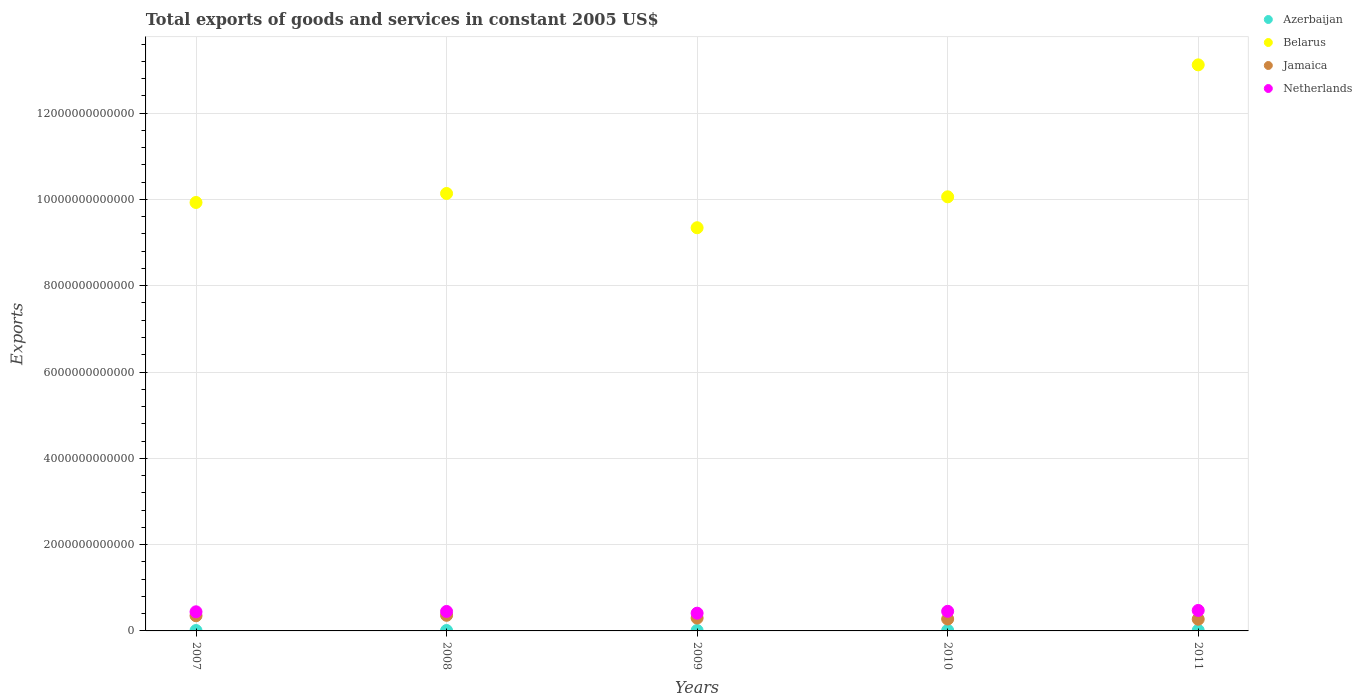How many different coloured dotlines are there?
Provide a short and direct response. 4. What is the total exports of goods and services in Belarus in 2011?
Offer a very short reply. 1.31e+13. Across all years, what is the maximum total exports of goods and services in Belarus?
Provide a succinct answer. 1.31e+13. Across all years, what is the minimum total exports of goods and services in Jamaica?
Give a very brief answer. 2.71e+11. In which year was the total exports of goods and services in Belarus maximum?
Offer a terse response. 2011. In which year was the total exports of goods and services in Netherlands minimum?
Provide a short and direct response. 2009. What is the total total exports of goods and services in Jamaica in the graph?
Your answer should be very brief. 1.56e+12. What is the difference between the total exports of goods and services in Netherlands in 2007 and that in 2009?
Your answer should be compact. 3.20e+1. What is the difference between the total exports of goods and services in Belarus in 2011 and the total exports of goods and services in Netherlands in 2009?
Your response must be concise. 1.27e+13. What is the average total exports of goods and services in Azerbaijan per year?
Your answer should be very brief. 1.10e+1. In the year 2008, what is the difference between the total exports of goods and services in Azerbaijan and total exports of goods and services in Belarus?
Ensure brevity in your answer.  -1.01e+13. In how many years, is the total exports of goods and services in Netherlands greater than 1200000000000 US$?
Provide a succinct answer. 0. What is the ratio of the total exports of goods and services in Belarus in 2009 to that in 2011?
Provide a short and direct response. 0.71. Is the total exports of goods and services in Jamaica in 2009 less than that in 2010?
Provide a succinct answer. No. What is the difference between the highest and the second highest total exports of goods and services in Belarus?
Ensure brevity in your answer.  2.98e+12. What is the difference between the highest and the lowest total exports of goods and services in Azerbaijan?
Provide a short and direct response. 4.42e+09. In how many years, is the total exports of goods and services in Belarus greater than the average total exports of goods and services in Belarus taken over all years?
Provide a short and direct response. 1. Does the total exports of goods and services in Azerbaijan monotonically increase over the years?
Give a very brief answer. Yes. Is the total exports of goods and services in Belarus strictly greater than the total exports of goods and services in Jamaica over the years?
Give a very brief answer. Yes. Is the total exports of goods and services in Belarus strictly less than the total exports of goods and services in Jamaica over the years?
Provide a succinct answer. No. How many years are there in the graph?
Your response must be concise. 5. What is the difference between two consecutive major ticks on the Y-axis?
Your response must be concise. 2.00e+12. How are the legend labels stacked?
Provide a succinct answer. Vertical. What is the title of the graph?
Your answer should be very brief. Total exports of goods and services in constant 2005 US$. Does "Ukraine" appear as one of the legend labels in the graph?
Offer a terse response. No. What is the label or title of the X-axis?
Offer a very short reply. Years. What is the label or title of the Y-axis?
Ensure brevity in your answer.  Exports. What is the Exports of Azerbaijan in 2007?
Keep it short and to the point. 8.85e+09. What is the Exports of Belarus in 2007?
Your answer should be compact. 9.93e+12. What is the Exports of Jamaica in 2007?
Keep it short and to the point. 3.52e+11. What is the Exports of Netherlands in 2007?
Provide a succinct answer. 4.43e+11. What is the Exports of Azerbaijan in 2008?
Your answer should be compact. 9.53e+09. What is the Exports of Belarus in 2008?
Make the answer very short. 1.01e+13. What is the Exports of Jamaica in 2008?
Provide a short and direct response. 3.62e+11. What is the Exports of Netherlands in 2008?
Offer a terse response. 4.51e+11. What is the Exports in Azerbaijan in 2009?
Your answer should be very brief. 1.03e+1. What is the Exports in Belarus in 2009?
Ensure brevity in your answer.  9.34e+12. What is the Exports in Jamaica in 2009?
Give a very brief answer. 2.98e+11. What is the Exports of Netherlands in 2009?
Your answer should be compact. 4.11e+11. What is the Exports in Azerbaijan in 2010?
Provide a short and direct response. 1.28e+1. What is the Exports in Belarus in 2010?
Ensure brevity in your answer.  1.01e+13. What is the Exports in Jamaica in 2010?
Give a very brief answer. 2.76e+11. What is the Exports of Netherlands in 2010?
Offer a very short reply. 4.54e+11. What is the Exports in Azerbaijan in 2011?
Your answer should be compact. 1.33e+1. What is the Exports of Belarus in 2011?
Give a very brief answer. 1.31e+13. What is the Exports of Jamaica in 2011?
Offer a very short reply. 2.71e+11. What is the Exports of Netherlands in 2011?
Provide a succinct answer. 4.74e+11. Across all years, what is the maximum Exports of Azerbaijan?
Give a very brief answer. 1.33e+1. Across all years, what is the maximum Exports in Belarus?
Provide a short and direct response. 1.31e+13. Across all years, what is the maximum Exports of Jamaica?
Your response must be concise. 3.62e+11. Across all years, what is the maximum Exports in Netherlands?
Your answer should be very brief. 4.74e+11. Across all years, what is the minimum Exports of Azerbaijan?
Make the answer very short. 8.85e+09. Across all years, what is the minimum Exports in Belarus?
Your answer should be very brief. 9.34e+12. Across all years, what is the minimum Exports in Jamaica?
Provide a short and direct response. 2.71e+11. Across all years, what is the minimum Exports of Netherlands?
Your response must be concise. 4.11e+11. What is the total Exports of Azerbaijan in the graph?
Your answer should be compact. 5.48e+1. What is the total Exports of Belarus in the graph?
Give a very brief answer. 5.26e+13. What is the total Exports in Jamaica in the graph?
Keep it short and to the point. 1.56e+12. What is the total Exports in Netherlands in the graph?
Your answer should be very brief. 2.23e+12. What is the difference between the Exports in Azerbaijan in 2007 and that in 2008?
Make the answer very short. -6.90e+08. What is the difference between the Exports in Belarus in 2007 and that in 2008?
Give a very brief answer. -2.09e+11. What is the difference between the Exports in Jamaica in 2007 and that in 2008?
Your answer should be compact. -1.02e+1. What is the difference between the Exports of Netherlands in 2007 and that in 2008?
Make the answer very short. -8.13e+09. What is the difference between the Exports in Azerbaijan in 2007 and that in 2009?
Your response must be concise. -1.47e+09. What is the difference between the Exports in Belarus in 2007 and that in 2009?
Make the answer very short. 5.85e+11. What is the difference between the Exports of Jamaica in 2007 and that in 2009?
Offer a terse response. 5.41e+1. What is the difference between the Exports in Netherlands in 2007 and that in 2009?
Give a very brief answer. 3.20e+1. What is the difference between the Exports in Azerbaijan in 2007 and that in 2010?
Offer a terse response. -3.96e+09. What is the difference between the Exports of Belarus in 2007 and that in 2010?
Your answer should be compact. -1.31e+11. What is the difference between the Exports in Jamaica in 2007 and that in 2010?
Your response must be concise. 7.63e+1. What is the difference between the Exports in Netherlands in 2007 and that in 2010?
Provide a succinct answer. -1.13e+1. What is the difference between the Exports of Azerbaijan in 2007 and that in 2011?
Offer a very short reply. -4.42e+09. What is the difference between the Exports of Belarus in 2007 and that in 2011?
Offer a terse response. -3.19e+12. What is the difference between the Exports in Jamaica in 2007 and that in 2011?
Ensure brevity in your answer.  8.05e+1. What is the difference between the Exports in Netherlands in 2007 and that in 2011?
Your answer should be compact. -3.13e+1. What is the difference between the Exports of Azerbaijan in 2008 and that in 2009?
Give a very brief answer. -7.75e+08. What is the difference between the Exports in Belarus in 2008 and that in 2009?
Give a very brief answer. 7.94e+11. What is the difference between the Exports in Jamaica in 2008 and that in 2009?
Offer a terse response. 6.43e+1. What is the difference between the Exports of Netherlands in 2008 and that in 2009?
Offer a terse response. 4.02e+1. What is the difference between the Exports in Azerbaijan in 2008 and that in 2010?
Your response must be concise. -3.27e+09. What is the difference between the Exports in Belarus in 2008 and that in 2010?
Make the answer very short. 7.74e+1. What is the difference between the Exports in Jamaica in 2008 and that in 2010?
Give a very brief answer. 8.65e+1. What is the difference between the Exports of Netherlands in 2008 and that in 2010?
Your response must be concise. -3.14e+09. What is the difference between the Exports of Azerbaijan in 2008 and that in 2011?
Provide a succinct answer. -3.73e+09. What is the difference between the Exports in Belarus in 2008 and that in 2011?
Ensure brevity in your answer.  -2.98e+12. What is the difference between the Exports in Jamaica in 2008 and that in 2011?
Keep it short and to the point. 9.07e+1. What is the difference between the Exports of Netherlands in 2008 and that in 2011?
Your answer should be compact. -2.32e+1. What is the difference between the Exports in Azerbaijan in 2009 and that in 2010?
Give a very brief answer. -2.50e+09. What is the difference between the Exports in Belarus in 2009 and that in 2010?
Offer a very short reply. -7.17e+11. What is the difference between the Exports of Jamaica in 2009 and that in 2010?
Ensure brevity in your answer.  2.22e+1. What is the difference between the Exports of Netherlands in 2009 and that in 2010?
Keep it short and to the point. -4.33e+1. What is the difference between the Exports of Azerbaijan in 2009 and that in 2011?
Provide a short and direct response. -2.96e+09. What is the difference between the Exports in Belarus in 2009 and that in 2011?
Keep it short and to the point. -3.77e+12. What is the difference between the Exports in Jamaica in 2009 and that in 2011?
Provide a short and direct response. 2.64e+1. What is the difference between the Exports in Netherlands in 2009 and that in 2011?
Give a very brief answer. -6.33e+1. What is the difference between the Exports of Azerbaijan in 2010 and that in 2011?
Offer a very short reply. -4.60e+08. What is the difference between the Exports of Belarus in 2010 and that in 2011?
Provide a short and direct response. -3.06e+12. What is the difference between the Exports in Jamaica in 2010 and that in 2011?
Your answer should be compact. 4.18e+09. What is the difference between the Exports in Netherlands in 2010 and that in 2011?
Provide a succinct answer. -2.00e+1. What is the difference between the Exports of Azerbaijan in 2007 and the Exports of Belarus in 2008?
Make the answer very short. -1.01e+13. What is the difference between the Exports of Azerbaijan in 2007 and the Exports of Jamaica in 2008?
Provide a short and direct response. -3.53e+11. What is the difference between the Exports of Azerbaijan in 2007 and the Exports of Netherlands in 2008?
Provide a short and direct response. -4.42e+11. What is the difference between the Exports of Belarus in 2007 and the Exports of Jamaica in 2008?
Ensure brevity in your answer.  9.57e+12. What is the difference between the Exports in Belarus in 2007 and the Exports in Netherlands in 2008?
Your response must be concise. 9.48e+12. What is the difference between the Exports in Jamaica in 2007 and the Exports in Netherlands in 2008?
Ensure brevity in your answer.  -9.94e+1. What is the difference between the Exports of Azerbaijan in 2007 and the Exports of Belarus in 2009?
Provide a short and direct response. -9.33e+12. What is the difference between the Exports in Azerbaijan in 2007 and the Exports in Jamaica in 2009?
Make the answer very short. -2.89e+11. What is the difference between the Exports of Azerbaijan in 2007 and the Exports of Netherlands in 2009?
Offer a very short reply. -4.02e+11. What is the difference between the Exports of Belarus in 2007 and the Exports of Jamaica in 2009?
Your response must be concise. 9.63e+12. What is the difference between the Exports of Belarus in 2007 and the Exports of Netherlands in 2009?
Offer a terse response. 9.52e+12. What is the difference between the Exports of Jamaica in 2007 and the Exports of Netherlands in 2009?
Your answer should be compact. -5.92e+1. What is the difference between the Exports in Azerbaijan in 2007 and the Exports in Belarus in 2010?
Your answer should be very brief. -1.01e+13. What is the difference between the Exports in Azerbaijan in 2007 and the Exports in Jamaica in 2010?
Offer a very short reply. -2.67e+11. What is the difference between the Exports of Azerbaijan in 2007 and the Exports of Netherlands in 2010?
Offer a very short reply. -4.46e+11. What is the difference between the Exports of Belarus in 2007 and the Exports of Jamaica in 2010?
Offer a terse response. 9.65e+12. What is the difference between the Exports in Belarus in 2007 and the Exports in Netherlands in 2010?
Your answer should be compact. 9.47e+12. What is the difference between the Exports in Jamaica in 2007 and the Exports in Netherlands in 2010?
Make the answer very short. -1.03e+11. What is the difference between the Exports in Azerbaijan in 2007 and the Exports in Belarus in 2011?
Your answer should be very brief. -1.31e+13. What is the difference between the Exports of Azerbaijan in 2007 and the Exports of Jamaica in 2011?
Your answer should be compact. -2.63e+11. What is the difference between the Exports in Azerbaijan in 2007 and the Exports in Netherlands in 2011?
Provide a succinct answer. -4.66e+11. What is the difference between the Exports of Belarus in 2007 and the Exports of Jamaica in 2011?
Your answer should be very brief. 9.66e+12. What is the difference between the Exports in Belarus in 2007 and the Exports in Netherlands in 2011?
Ensure brevity in your answer.  9.45e+12. What is the difference between the Exports in Jamaica in 2007 and the Exports in Netherlands in 2011?
Ensure brevity in your answer.  -1.23e+11. What is the difference between the Exports in Azerbaijan in 2008 and the Exports in Belarus in 2009?
Ensure brevity in your answer.  -9.33e+12. What is the difference between the Exports of Azerbaijan in 2008 and the Exports of Jamaica in 2009?
Give a very brief answer. -2.88e+11. What is the difference between the Exports in Azerbaijan in 2008 and the Exports in Netherlands in 2009?
Give a very brief answer. -4.02e+11. What is the difference between the Exports of Belarus in 2008 and the Exports of Jamaica in 2009?
Offer a terse response. 9.84e+12. What is the difference between the Exports in Belarus in 2008 and the Exports in Netherlands in 2009?
Offer a terse response. 9.73e+12. What is the difference between the Exports of Jamaica in 2008 and the Exports of Netherlands in 2009?
Your answer should be compact. -4.90e+1. What is the difference between the Exports in Azerbaijan in 2008 and the Exports in Belarus in 2010?
Provide a short and direct response. -1.01e+13. What is the difference between the Exports of Azerbaijan in 2008 and the Exports of Jamaica in 2010?
Provide a succinct answer. -2.66e+11. What is the difference between the Exports in Azerbaijan in 2008 and the Exports in Netherlands in 2010?
Offer a very short reply. -4.45e+11. What is the difference between the Exports in Belarus in 2008 and the Exports in Jamaica in 2010?
Offer a terse response. 9.86e+12. What is the difference between the Exports in Belarus in 2008 and the Exports in Netherlands in 2010?
Keep it short and to the point. 9.68e+12. What is the difference between the Exports in Jamaica in 2008 and the Exports in Netherlands in 2010?
Provide a succinct answer. -9.23e+1. What is the difference between the Exports in Azerbaijan in 2008 and the Exports in Belarus in 2011?
Ensure brevity in your answer.  -1.31e+13. What is the difference between the Exports of Azerbaijan in 2008 and the Exports of Jamaica in 2011?
Your answer should be very brief. -2.62e+11. What is the difference between the Exports in Azerbaijan in 2008 and the Exports in Netherlands in 2011?
Your answer should be compact. -4.65e+11. What is the difference between the Exports in Belarus in 2008 and the Exports in Jamaica in 2011?
Provide a short and direct response. 9.87e+12. What is the difference between the Exports of Belarus in 2008 and the Exports of Netherlands in 2011?
Give a very brief answer. 9.66e+12. What is the difference between the Exports in Jamaica in 2008 and the Exports in Netherlands in 2011?
Your response must be concise. -1.12e+11. What is the difference between the Exports in Azerbaijan in 2009 and the Exports in Belarus in 2010?
Give a very brief answer. -1.00e+13. What is the difference between the Exports of Azerbaijan in 2009 and the Exports of Jamaica in 2010?
Make the answer very short. -2.65e+11. What is the difference between the Exports of Azerbaijan in 2009 and the Exports of Netherlands in 2010?
Make the answer very short. -4.44e+11. What is the difference between the Exports in Belarus in 2009 and the Exports in Jamaica in 2010?
Give a very brief answer. 9.07e+12. What is the difference between the Exports of Belarus in 2009 and the Exports of Netherlands in 2010?
Keep it short and to the point. 8.89e+12. What is the difference between the Exports in Jamaica in 2009 and the Exports in Netherlands in 2010?
Your answer should be very brief. -1.57e+11. What is the difference between the Exports of Azerbaijan in 2009 and the Exports of Belarus in 2011?
Your answer should be compact. -1.31e+13. What is the difference between the Exports of Azerbaijan in 2009 and the Exports of Jamaica in 2011?
Provide a succinct answer. -2.61e+11. What is the difference between the Exports of Azerbaijan in 2009 and the Exports of Netherlands in 2011?
Your answer should be very brief. -4.64e+11. What is the difference between the Exports in Belarus in 2009 and the Exports in Jamaica in 2011?
Offer a terse response. 9.07e+12. What is the difference between the Exports in Belarus in 2009 and the Exports in Netherlands in 2011?
Give a very brief answer. 8.87e+12. What is the difference between the Exports of Jamaica in 2009 and the Exports of Netherlands in 2011?
Keep it short and to the point. -1.77e+11. What is the difference between the Exports of Azerbaijan in 2010 and the Exports of Belarus in 2011?
Provide a short and direct response. -1.31e+13. What is the difference between the Exports of Azerbaijan in 2010 and the Exports of Jamaica in 2011?
Offer a very short reply. -2.59e+11. What is the difference between the Exports of Azerbaijan in 2010 and the Exports of Netherlands in 2011?
Make the answer very short. -4.62e+11. What is the difference between the Exports of Belarus in 2010 and the Exports of Jamaica in 2011?
Offer a very short reply. 9.79e+12. What is the difference between the Exports in Belarus in 2010 and the Exports in Netherlands in 2011?
Provide a short and direct response. 9.59e+12. What is the difference between the Exports of Jamaica in 2010 and the Exports of Netherlands in 2011?
Offer a very short reply. -1.99e+11. What is the average Exports of Azerbaijan per year?
Your answer should be very brief. 1.10e+1. What is the average Exports in Belarus per year?
Provide a short and direct response. 1.05e+13. What is the average Exports of Jamaica per year?
Your answer should be very brief. 3.12e+11. What is the average Exports of Netherlands per year?
Your answer should be compact. 4.47e+11. In the year 2007, what is the difference between the Exports in Azerbaijan and Exports in Belarus?
Keep it short and to the point. -9.92e+12. In the year 2007, what is the difference between the Exports in Azerbaijan and Exports in Jamaica?
Your answer should be compact. -3.43e+11. In the year 2007, what is the difference between the Exports in Azerbaijan and Exports in Netherlands?
Offer a very short reply. -4.34e+11. In the year 2007, what is the difference between the Exports of Belarus and Exports of Jamaica?
Ensure brevity in your answer.  9.58e+12. In the year 2007, what is the difference between the Exports of Belarus and Exports of Netherlands?
Provide a short and direct response. 9.49e+12. In the year 2007, what is the difference between the Exports in Jamaica and Exports in Netherlands?
Offer a terse response. -9.13e+1. In the year 2008, what is the difference between the Exports in Azerbaijan and Exports in Belarus?
Your response must be concise. -1.01e+13. In the year 2008, what is the difference between the Exports of Azerbaijan and Exports of Jamaica?
Provide a short and direct response. -3.53e+11. In the year 2008, what is the difference between the Exports of Azerbaijan and Exports of Netherlands?
Your response must be concise. -4.42e+11. In the year 2008, what is the difference between the Exports of Belarus and Exports of Jamaica?
Offer a terse response. 9.78e+12. In the year 2008, what is the difference between the Exports in Belarus and Exports in Netherlands?
Your answer should be compact. 9.69e+12. In the year 2008, what is the difference between the Exports in Jamaica and Exports in Netherlands?
Provide a short and direct response. -8.92e+1. In the year 2009, what is the difference between the Exports in Azerbaijan and Exports in Belarus?
Offer a very short reply. -9.33e+12. In the year 2009, what is the difference between the Exports in Azerbaijan and Exports in Jamaica?
Offer a very short reply. -2.87e+11. In the year 2009, what is the difference between the Exports in Azerbaijan and Exports in Netherlands?
Offer a very short reply. -4.01e+11. In the year 2009, what is the difference between the Exports of Belarus and Exports of Jamaica?
Ensure brevity in your answer.  9.05e+12. In the year 2009, what is the difference between the Exports of Belarus and Exports of Netherlands?
Your response must be concise. 8.93e+12. In the year 2009, what is the difference between the Exports of Jamaica and Exports of Netherlands?
Your answer should be very brief. -1.13e+11. In the year 2010, what is the difference between the Exports in Azerbaijan and Exports in Belarus?
Your answer should be compact. -1.00e+13. In the year 2010, what is the difference between the Exports of Azerbaijan and Exports of Jamaica?
Provide a short and direct response. -2.63e+11. In the year 2010, what is the difference between the Exports in Azerbaijan and Exports in Netherlands?
Your response must be concise. -4.42e+11. In the year 2010, what is the difference between the Exports in Belarus and Exports in Jamaica?
Keep it short and to the point. 9.78e+12. In the year 2010, what is the difference between the Exports in Belarus and Exports in Netherlands?
Your response must be concise. 9.61e+12. In the year 2010, what is the difference between the Exports in Jamaica and Exports in Netherlands?
Your answer should be compact. -1.79e+11. In the year 2011, what is the difference between the Exports in Azerbaijan and Exports in Belarus?
Provide a short and direct response. -1.31e+13. In the year 2011, what is the difference between the Exports in Azerbaijan and Exports in Jamaica?
Make the answer very short. -2.58e+11. In the year 2011, what is the difference between the Exports of Azerbaijan and Exports of Netherlands?
Make the answer very short. -4.61e+11. In the year 2011, what is the difference between the Exports of Belarus and Exports of Jamaica?
Provide a succinct answer. 1.28e+13. In the year 2011, what is the difference between the Exports in Belarus and Exports in Netherlands?
Give a very brief answer. 1.26e+13. In the year 2011, what is the difference between the Exports in Jamaica and Exports in Netherlands?
Keep it short and to the point. -2.03e+11. What is the ratio of the Exports in Azerbaijan in 2007 to that in 2008?
Your answer should be compact. 0.93. What is the ratio of the Exports of Belarus in 2007 to that in 2008?
Your response must be concise. 0.98. What is the ratio of the Exports of Jamaica in 2007 to that in 2008?
Your answer should be compact. 0.97. What is the ratio of the Exports of Netherlands in 2007 to that in 2008?
Your answer should be compact. 0.98. What is the ratio of the Exports in Azerbaijan in 2007 to that in 2009?
Offer a very short reply. 0.86. What is the ratio of the Exports of Belarus in 2007 to that in 2009?
Give a very brief answer. 1.06. What is the ratio of the Exports in Jamaica in 2007 to that in 2009?
Ensure brevity in your answer.  1.18. What is the ratio of the Exports of Netherlands in 2007 to that in 2009?
Your response must be concise. 1.08. What is the ratio of the Exports in Azerbaijan in 2007 to that in 2010?
Give a very brief answer. 0.69. What is the ratio of the Exports in Belarus in 2007 to that in 2010?
Provide a succinct answer. 0.99. What is the ratio of the Exports in Jamaica in 2007 to that in 2010?
Offer a very short reply. 1.28. What is the ratio of the Exports of Netherlands in 2007 to that in 2010?
Ensure brevity in your answer.  0.98. What is the ratio of the Exports of Azerbaijan in 2007 to that in 2011?
Provide a succinct answer. 0.67. What is the ratio of the Exports of Belarus in 2007 to that in 2011?
Offer a very short reply. 0.76. What is the ratio of the Exports of Jamaica in 2007 to that in 2011?
Provide a succinct answer. 1.3. What is the ratio of the Exports in Netherlands in 2007 to that in 2011?
Provide a short and direct response. 0.93. What is the ratio of the Exports of Azerbaijan in 2008 to that in 2009?
Keep it short and to the point. 0.92. What is the ratio of the Exports of Belarus in 2008 to that in 2009?
Your response must be concise. 1.08. What is the ratio of the Exports of Jamaica in 2008 to that in 2009?
Provide a short and direct response. 1.22. What is the ratio of the Exports of Netherlands in 2008 to that in 2009?
Your answer should be compact. 1.1. What is the ratio of the Exports of Azerbaijan in 2008 to that in 2010?
Your answer should be very brief. 0.74. What is the ratio of the Exports of Belarus in 2008 to that in 2010?
Your response must be concise. 1.01. What is the ratio of the Exports in Jamaica in 2008 to that in 2010?
Give a very brief answer. 1.31. What is the ratio of the Exports in Azerbaijan in 2008 to that in 2011?
Make the answer very short. 0.72. What is the ratio of the Exports in Belarus in 2008 to that in 2011?
Provide a succinct answer. 0.77. What is the ratio of the Exports in Jamaica in 2008 to that in 2011?
Provide a succinct answer. 1.33. What is the ratio of the Exports of Netherlands in 2008 to that in 2011?
Make the answer very short. 0.95. What is the ratio of the Exports in Azerbaijan in 2009 to that in 2010?
Your answer should be very brief. 0.81. What is the ratio of the Exports of Belarus in 2009 to that in 2010?
Your answer should be very brief. 0.93. What is the ratio of the Exports in Jamaica in 2009 to that in 2010?
Your answer should be very brief. 1.08. What is the ratio of the Exports of Netherlands in 2009 to that in 2010?
Make the answer very short. 0.9. What is the ratio of the Exports in Azerbaijan in 2009 to that in 2011?
Give a very brief answer. 0.78. What is the ratio of the Exports of Belarus in 2009 to that in 2011?
Provide a succinct answer. 0.71. What is the ratio of the Exports of Jamaica in 2009 to that in 2011?
Your answer should be compact. 1.1. What is the ratio of the Exports in Netherlands in 2009 to that in 2011?
Provide a succinct answer. 0.87. What is the ratio of the Exports of Azerbaijan in 2010 to that in 2011?
Your answer should be compact. 0.97. What is the ratio of the Exports of Belarus in 2010 to that in 2011?
Your answer should be very brief. 0.77. What is the ratio of the Exports of Jamaica in 2010 to that in 2011?
Offer a terse response. 1.02. What is the ratio of the Exports in Netherlands in 2010 to that in 2011?
Offer a very short reply. 0.96. What is the difference between the highest and the second highest Exports in Azerbaijan?
Your answer should be very brief. 4.60e+08. What is the difference between the highest and the second highest Exports of Belarus?
Make the answer very short. 2.98e+12. What is the difference between the highest and the second highest Exports of Jamaica?
Offer a terse response. 1.02e+1. What is the difference between the highest and the second highest Exports in Netherlands?
Give a very brief answer. 2.00e+1. What is the difference between the highest and the lowest Exports of Azerbaijan?
Your answer should be very brief. 4.42e+09. What is the difference between the highest and the lowest Exports in Belarus?
Provide a short and direct response. 3.77e+12. What is the difference between the highest and the lowest Exports in Jamaica?
Your answer should be very brief. 9.07e+1. What is the difference between the highest and the lowest Exports of Netherlands?
Offer a terse response. 6.33e+1. 